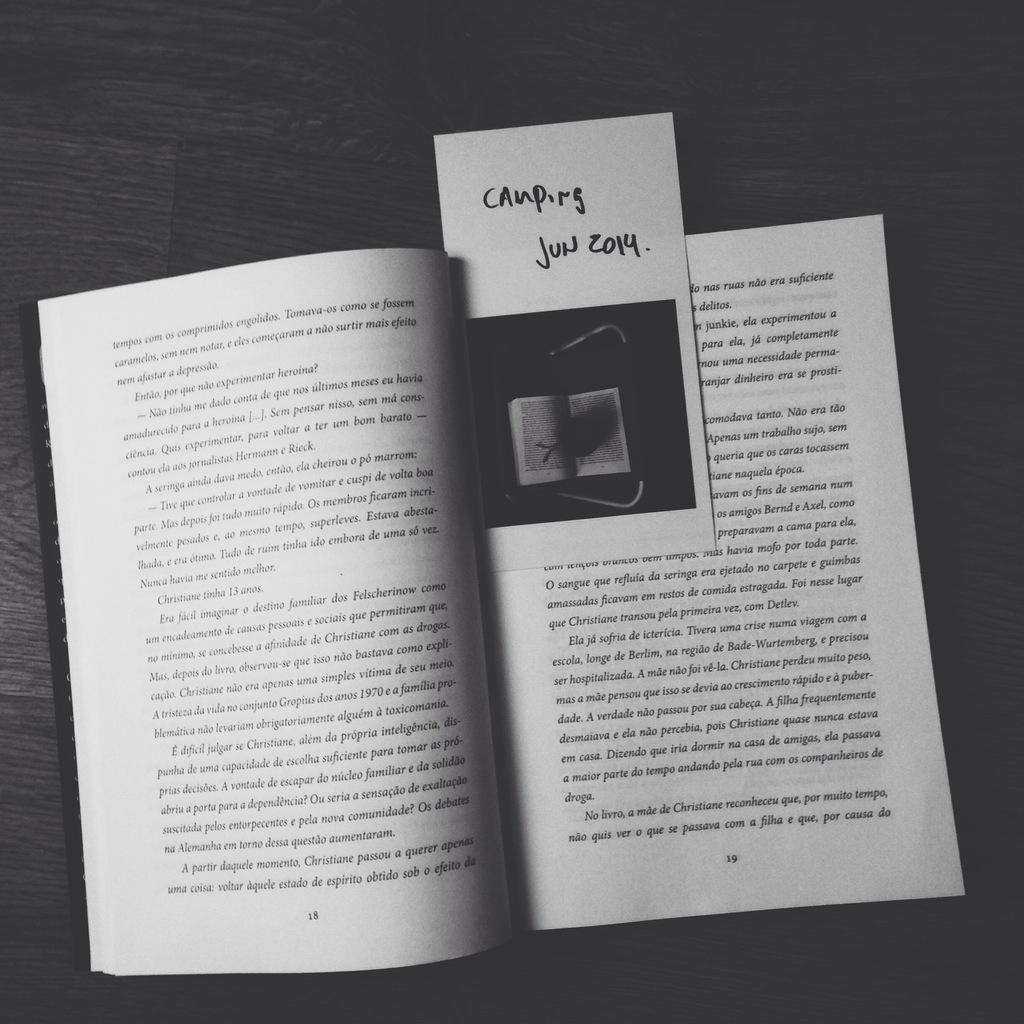<image>
Relay a brief, clear account of the picture shown. A book is opened up to page 19 in June of 2014 